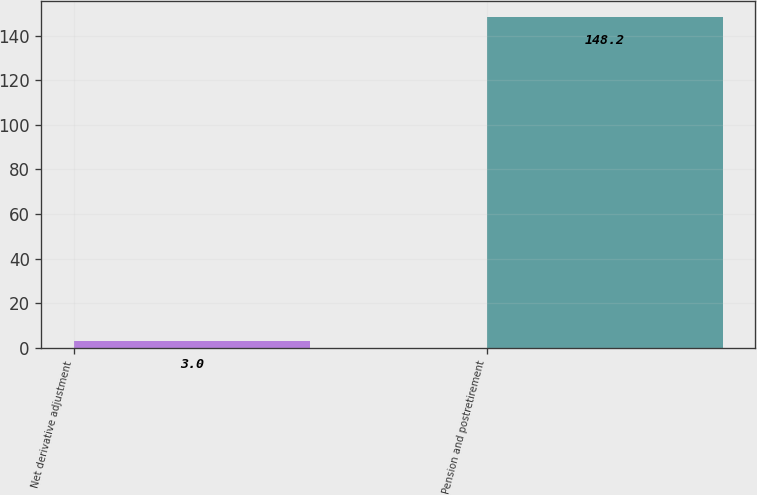Convert chart. <chart><loc_0><loc_0><loc_500><loc_500><bar_chart><fcel>Net derivative adjustment<fcel>Pension and postretirement<nl><fcel>3<fcel>148.2<nl></chart> 